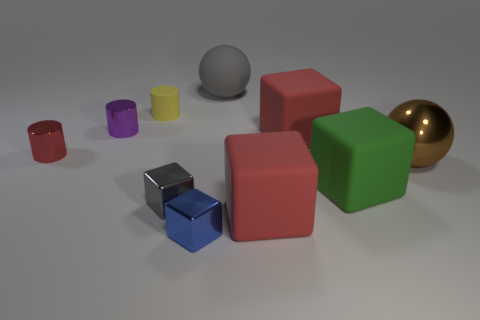What number of tiny things have the same color as the large matte ball?
Keep it short and to the point. 1. What is the shape of the metallic thing that is the same color as the matte ball?
Ensure brevity in your answer.  Cube. There is a large ball that is in front of the sphere that is to the left of the brown object; what is its color?
Your answer should be very brief. Brown. What is the color of the other metal thing that is the same shape as the blue object?
Provide a succinct answer. Gray. Are there any other things that are made of the same material as the blue cube?
Offer a very short reply. Yes. What is the size of the green rubber object that is the same shape as the tiny gray thing?
Provide a short and direct response. Large. There is a big red block behind the brown object; what material is it?
Offer a terse response. Rubber. Are there fewer brown metal balls in front of the small purple shiny object than tiny purple metallic cylinders?
Your answer should be compact. No. There is a big red rubber thing in front of the small shiny cube that is left of the small blue cube; what shape is it?
Offer a very short reply. Cube. What is the color of the small matte cylinder?
Make the answer very short. Yellow. 